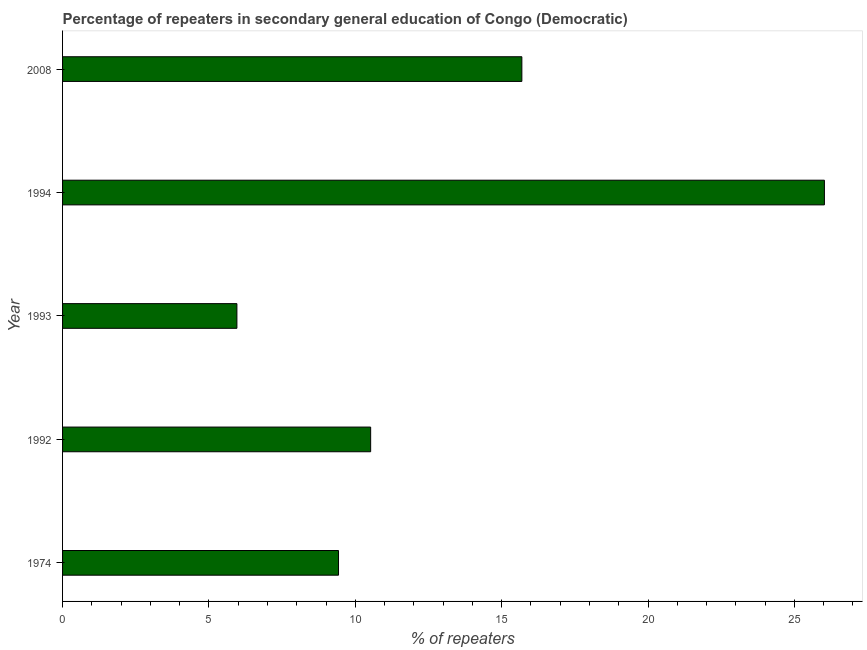What is the title of the graph?
Your response must be concise. Percentage of repeaters in secondary general education of Congo (Democratic). What is the label or title of the X-axis?
Offer a terse response. % of repeaters. What is the percentage of repeaters in 1993?
Offer a very short reply. 5.96. Across all years, what is the maximum percentage of repeaters?
Your answer should be very brief. 26.02. Across all years, what is the minimum percentage of repeaters?
Keep it short and to the point. 5.96. What is the sum of the percentage of repeaters?
Give a very brief answer. 67.62. What is the difference between the percentage of repeaters in 1992 and 1994?
Your response must be concise. -15.5. What is the average percentage of repeaters per year?
Offer a terse response. 13.52. What is the median percentage of repeaters?
Offer a very short reply. 10.52. In how many years, is the percentage of repeaters greater than 9 %?
Offer a terse response. 4. What is the ratio of the percentage of repeaters in 1992 to that in 1994?
Give a very brief answer. 0.4. Is the percentage of repeaters in 1974 less than that in 1992?
Provide a succinct answer. Yes. Is the difference between the percentage of repeaters in 1974 and 1994 greater than the difference between any two years?
Your answer should be compact. No. What is the difference between the highest and the second highest percentage of repeaters?
Offer a very short reply. 10.34. Is the sum of the percentage of repeaters in 1992 and 1994 greater than the maximum percentage of repeaters across all years?
Provide a short and direct response. Yes. What is the difference between the highest and the lowest percentage of repeaters?
Your response must be concise. 20.07. Are all the bars in the graph horizontal?
Ensure brevity in your answer.  Yes. How many years are there in the graph?
Your response must be concise. 5. Are the values on the major ticks of X-axis written in scientific E-notation?
Your answer should be compact. No. What is the % of repeaters of 1974?
Keep it short and to the point. 9.43. What is the % of repeaters in 1992?
Make the answer very short. 10.52. What is the % of repeaters in 1993?
Keep it short and to the point. 5.96. What is the % of repeaters of 1994?
Offer a terse response. 26.02. What is the % of repeaters in 2008?
Make the answer very short. 15.69. What is the difference between the % of repeaters in 1974 and 1992?
Make the answer very short. -1.1. What is the difference between the % of repeaters in 1974 and 1993?
Give a very brief answer. 3.47. What is the difference between the % of repeaters in 1974 and 1994?
Your answer should be compact. -16.6. What is the difference between the % of repeaters in 1974 and 2008?
Provide a short and direct response. -6.26. What is the difference between the % of repeaters in 1992 and 1993?
Ensure brevity in your answer.  4.57. What is the difference between the % of repeaters in 1992 and 1994?
Give a very brief answer. -15.5. What is the difference between the % of repeaters in 1992 and 2008?
Your answer should be very brief. -5.17. What is the difference between the % of repeaters in 1993 and 1994?
Provide a short and direct response. -20.07. What is the difference between the % of repeaters in 1993 and 2008?
Offer a terse response. -9.73. What is the difference between the % of repeaters in 1994 and 2008?
Keep it short and to the point. 10.33. What is the ratio of the % of repeaters in 1974 to that in 1992?
Your answer should be compact. 0.9. What is the ratio of the % of repeaters in 1974 to that in 1993?
Keep it short and to the point. 1.58. What is the ratio of the % of repeaters in 1974 to that in 1994?
Your answer should be compact. 0.36. What is the ratio of the % of repeaters in 1974 to that in 2008?
Offer a terse response. 0.6. What is the ratio of the % of repeaters in 1992 to that in 1993?
Give a very brief answer. 1.77. What is the ratio of the % of repeaters in 1992 to that in 1994?
Offer a terse response. 0.4. What is the ratio of the % of repeaters in 1992 to that in 2008?
Give a very brief answer. 0.67. What is the ratio of the % of repeaters in 1993 to that in 1994?
Ensure brevity in your answer.  0.23. What is the ratio of the % of repeaters in 1993 to that in 2008?
Provide a succinct answer. 0.38. What is the ratio of the % of repeaters in 1994 to that in 2008?
Give a very brief answer. 1.66. 